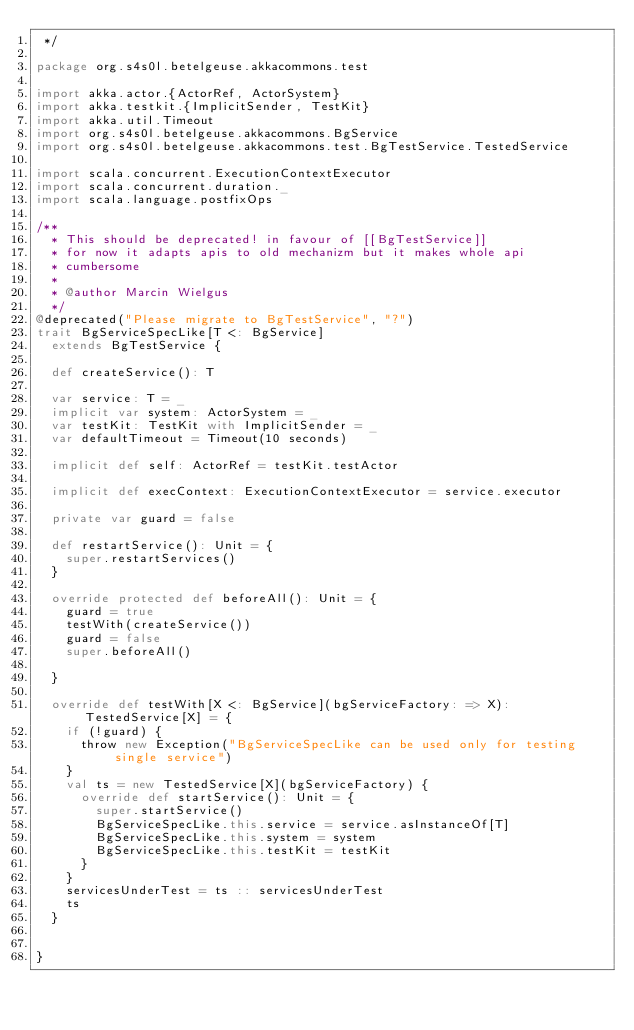Convert code to text. <code><loc_0><loc_0><loc_500><loc_500><_Scala_> */

package org.s4s0l.betelgeuse.akkacommons.test

import akka.actor.{ActorRef, ActorSystem}
import akka.testkit.{ImplicitSender, TestKit}
import akka.util.Timeout
import org.s4s0l.betelgeuse.akkacommons.BgService
import org.s4s0l.betelgeuse.akkacommons.test.BgTestService.TestedService

import scala.concurrent.ExecutionContextExecutor
import scala.concurrent.duration._
import scala.language.postfixOps

/**
  * This should be deprecated! in favour of [[BgTestService]]
  * for now it adapts apis to old mechanizm but it makes whole api
  * cumbersome
  *
  * @author Marcin Wielgus
  */
@deprecated("Please migrate to BgTestService", "?")
trait BgServiceSpecLike[T <: BgService]
  extends BgTestService {

  def createService(): T

  var service: T = _
  implicit var system: ActorSystem = _
  var testKit: TestKit with ImplicitSender = _
  var defaultTimeout = Timeout(10 seconds)

  implicit def self: ActorRef = testKit.testActor

  implicit def execContext: ExecutionContextExecutor = service.executor

  private var guard = false

  def restartService(): Unit = {
    super.restartServices()
  }

  override protected def beforeAll(): Unit = {
    guard = true
    testWith(createService())
    guard = false
    super.beforeAll()

  }

  override def testWith[X <: BgService](bgServiceFactory: => X): TestedService[X] = {
    if (!guard) {
      throw new Exception("BgServiceSpecLike can be used only for testing single service")
    }
    val ts = new TestedService[X](bgServiceFactory) {
      override def startService(): Unit = {
        super.startService()
        BgServiceSpecLike.this.service = service.asInstanceOf[T]
        BgServiceSpecLike.this.system = system
        BgServiceSpecLike.this.testKit = testKit
      }
    }
    servicesUnderTest = ts :: servicesUnderTest
    ts
  }


}
</code> 